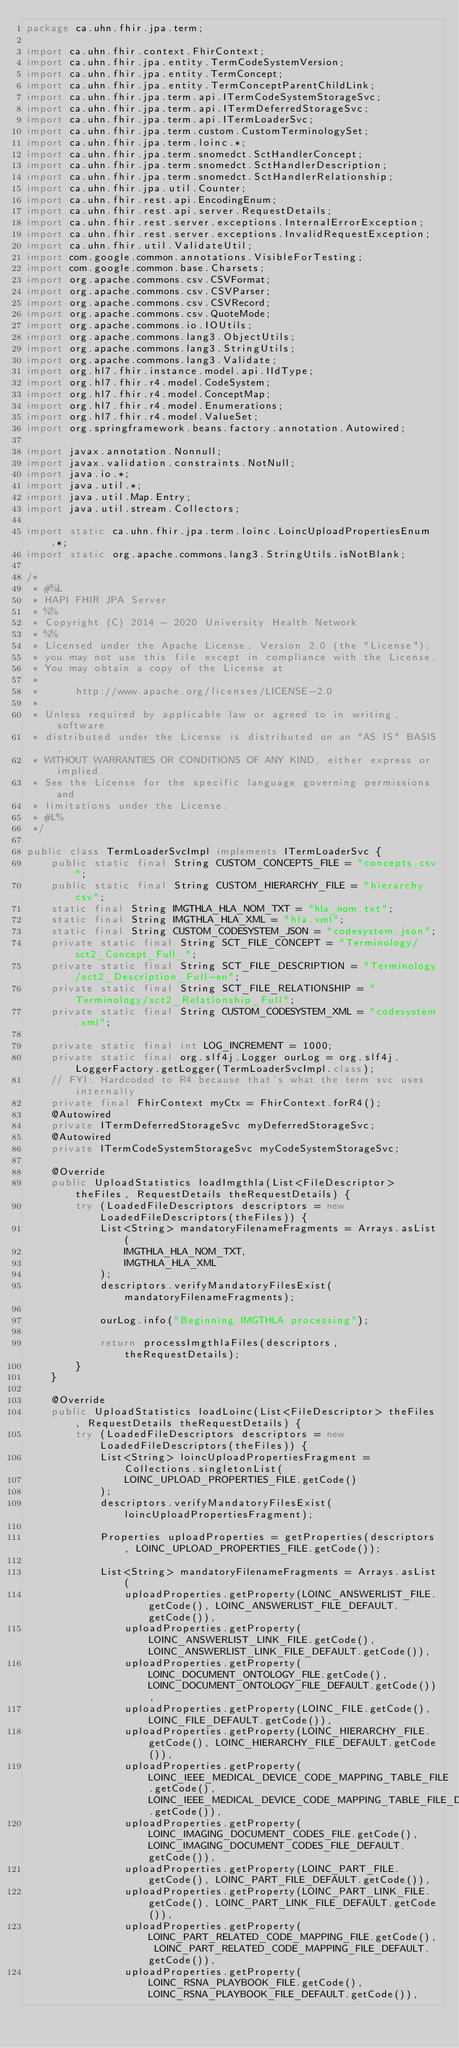Convert code to text. <code><loc_0><loc_0><loc_500><loc_500><_Java_>package ca.uhn.fhir.jpa.term;

import ca.uhn.fhir.context.FhirContext;
import ca.uhn.fhir.jpa.entity.TermCodeSystemVersion;
import ca.uhn.fhir.jpa.entity.TermConcept;
import ca.uhn.fhir.jpa.entity.TermConceptParentChildLink;
import ca.uhn.fhir.jpa.term.api.ITermCodeSystemStorageSvc;
import ca.uhn.fhir.jpa.term.api.ITermDeferredStorageSvc;
import ca.uhn.fhir.jpa.term.api.ITermLoaderSvc;
import ca.uhn.fhir.jpa.term.custom.CustomTerminologySet;
import ca.uhn.fhir.jpa.term.loinc.*;
import ca.uhn.fhir.jpa.term.snomedct.SctHandlerConcept;
import ca.uhn.fhir.jpa.term.snomedct.SctHandlerDescription;
import ca.uhn.fhir.jpa.term.snomedct.SctHandlerRelationship;
import ca.uhn.fhir.jpa.util.Counter;
import ca.uhn.fhir.rest.api.EncodingEnum;
import ca.uhn.fhir.rest.api.server.RequestDetails;
import ca.uhn.fhir.rest.server.exceptions.InternalErrorException;
import ca.uhn.fhir.rest.server.exceptions.InvalidRequestException;
import ca.uhn.fhir.util.ValidateUtil;
import com.google.common.annotations.VisibleForTesting;
import com.google.common.base.Charsets;
import org.apache.commons.csv.CSVFormat;
import org.apache.commons.csv.CSVParser;
import org.apache.commons.csv.CSVRecord;
import org.apache.commons.csv.QuoteMode;
import org.apache.commons.io.IOUtils;
import org.apache.commons.lang3.ObjectUtils;
import org.apache.commons.lang3.StringUtils;
import org.apache.commons.lang3.Validate;
import org.hl7.fhir.instance.model.api.IIdType;
import org.hl7.fhir.r4.model.CodeSystem;
import org.hl7.fhir.r4.model.ConceptMap;
import org.hl7.fhir.r4.model.Enumerations;
import org.hl7.fhir.r4.model.ValueSet;
import org.springframework.beans.factory.annotation.Autowired;

import javax.annotation.Nonnull;
import javax.validation.constraints.NotNull;
import java.io.*;
import java.util.*;
import java.util.Map.Entry;
import java.util.stream.Collectors;

import static ca.uhn.fhir.jpa.term.loinc.LoincUploadPropertiesEnum.*;
import static org.apache.commons.lang3.StringUtils.isNotBlank;

/*
 * #%L
 * HAPI FHIR JPA Server
 * %%
 * Copyright (C) 2014 - 2020 University Health Network
 * %%
 * Licensed under the Apache License, Version 2.0 (the "License");
 * you may not use this file except in compliance with the License.
 * You may obtain a copy of the License at
 *
 *      http://www.apache.org/licenses/LICENSE-2.0
 *
 * Unless required by applicable law or agreed to in writing, software
 * distributed under the License is distributed on an "AS IS" BASIS,
 * WITHOUT WARRANTIES OR CONDITIONS OF ANY KIND, either express or implied.
 * See the License for the specific language governing permissions and
 * limitations under the License.
 * #L%
 */

public class TermLoaderSvcImpl implements ITermLoaderSvc {
	public static final String CUSTOM_CONCEPTS_FILE = "concepts.csv";
	public static final String CUSTOM_HIERARCHY_FILE = "hierarchy.csv";
	static final String IMGTHLA_HLA_NOM_TXT = "hla_nom.txt";
	static final String IMGTHLA_HLA_XML = "hla.xml";
	static final String CUSTOM_CODESYSTEM_JSON = "codesystem.json";
	private static final String SCT_FILE_CONCEPT = "Terminology/sct2_Concept_Full_";
	private static final String SCT_FILE_DESCRIPTION = "Terminology/sct2_Description_Full-en";
	private static final String SCT_FILE_RELATIONSHIP = "Terminology/sct2_Relationship_Full";
	private static final String CUSTOM_CODESYSTEM_XML = "codesystem.xml";

	private static final int LOG_INCREMENT = 1000;
	private static final org.slf4j.Logger ourLog = org.slf4j.LoggerFactory.getLogger(TermLoaderSvcImpl.class);
	// FYI: Hardcoded to R4 because that's what the term svc uses internally
	private final FhirContext myCtx = FhirContext.forR4();
	@Autowired
	private ITermDeferredStorageSvc myDeferredStorageSvc;
	@Autowired
	private ITermCodeSystemStorageSvc myCodeSystemStorageSvc;

	@Override
	public UploadStatistics loadImgthla(List<FileDescriptor> theFiles, RequestDetails theRequestDetails) {
		try (LoadedFileDescriptors descriptors = new LoadedFileDescriptors(theFiles)) {
			List<String> mandatoryFilenameFragments = Arrays.asList(
				IMGTHLA_HLA_NOM_TXT,
				IMGTHLA_HLA_XML
			);
			descriptors.verifyMandatoryFilesExist(mandatoryFilenameFragments);

			ourLog.info("Beginning IMGTHLA processing");

			return processImgthlaFiles(descriptors, theRequestDetails);
		}
	}

	@Override
	public UploadStatistics loadLoinc(List<FileDescriptor> theFiles, RequestDetails theRequestDetails) {
		try (LoadedFileDescriptors descriptors = new LoadedFileDescriptors(theFiles)) {
			List<String> loincUploadPropertiesFragment = Collections.singletonList(
				LOINC_UPLOAD_PROPERTIES_FILE.getCode()
			);
			descriptors.verifyMandatoryFilesExist(loincUploadPropertiesFragment);

			Properties uploadProperties = getProperties(descriptors, LOINC_UPLOAD_PROPERTIES_FILE.getCode());

			List<String> mandatoryFilenameFragments = Arrays.asList(
				uploadProperties.getProperty(LOINC_ANSWERLIST_FILE.getCode(), LOINC_ANSWERLIST_FILE_DEFAULT.getCode()),
				uploadProperties.getProperty(LOINC_ANSWERLIST_LINK_FILE.getCode(), LOINC_ANSWERLIST_LINK_FILE_DEFAULT.getCode()),
				uploadProperties.getProperty(LOINC_DOCUMENT_ONTOLOGY_FILE.getCode(), LOINC_DOCUMENT_ONTOLOGY_FILE_DEFAULT.getCode()),
				uploadProperties.getProperty(LOINC_FILE.getCode(), LOINC_FILE_DEFAULT.getCode()),
				uploadProperties.getProperty(LOINC_HIERARCHY_FILE.getCode(), LOINC_HIERARCHY_FILE_DEFAULT.getCode()),
				uploadProperties.getProperty(LOINC_IEEE_MEDICAL_DEVICE_CODE_MAPPING_TABLE_FILE.getCode(), LOINC_IEEE_MEDICAL_DEVICE_CODE_MAPPING_TABLE_FILE_DEFAULT.getCode()),
				uploadProperties.getProperty(LOINC_IMAGING_DOCUMENT_CODES_FILE.getCode(), LOINC_IMAGING_DOCUMENT_CODES_FILE_DEFAULT.getCode()),
				uploadProperties.getProperty(LOINC_PART_FILE.getCode(), LOINC_PART_FILE_DEFAULT.getCode()),
				uploadProperties.getProperty(LOINC_PART_LINK_FILE.getCode(), LOINC_PART_LINK_FILE_DEFAULT.getCode()),
				uploadProperties.getProperty(LOINC_PART_RELATED_CODE_MAPPING_FILE.getCode(), LOINC_PART_RELATED_CODE_MAPPING_FILE_DEFAULT.getCode()),
				uploadProperties.getProperty(LOINC_RSNA_PLAYBOOK_FILE.getCode(), LOINC_RSNA_PLAYBOOK_FILE_DEFAULT.getCode()),</code> 